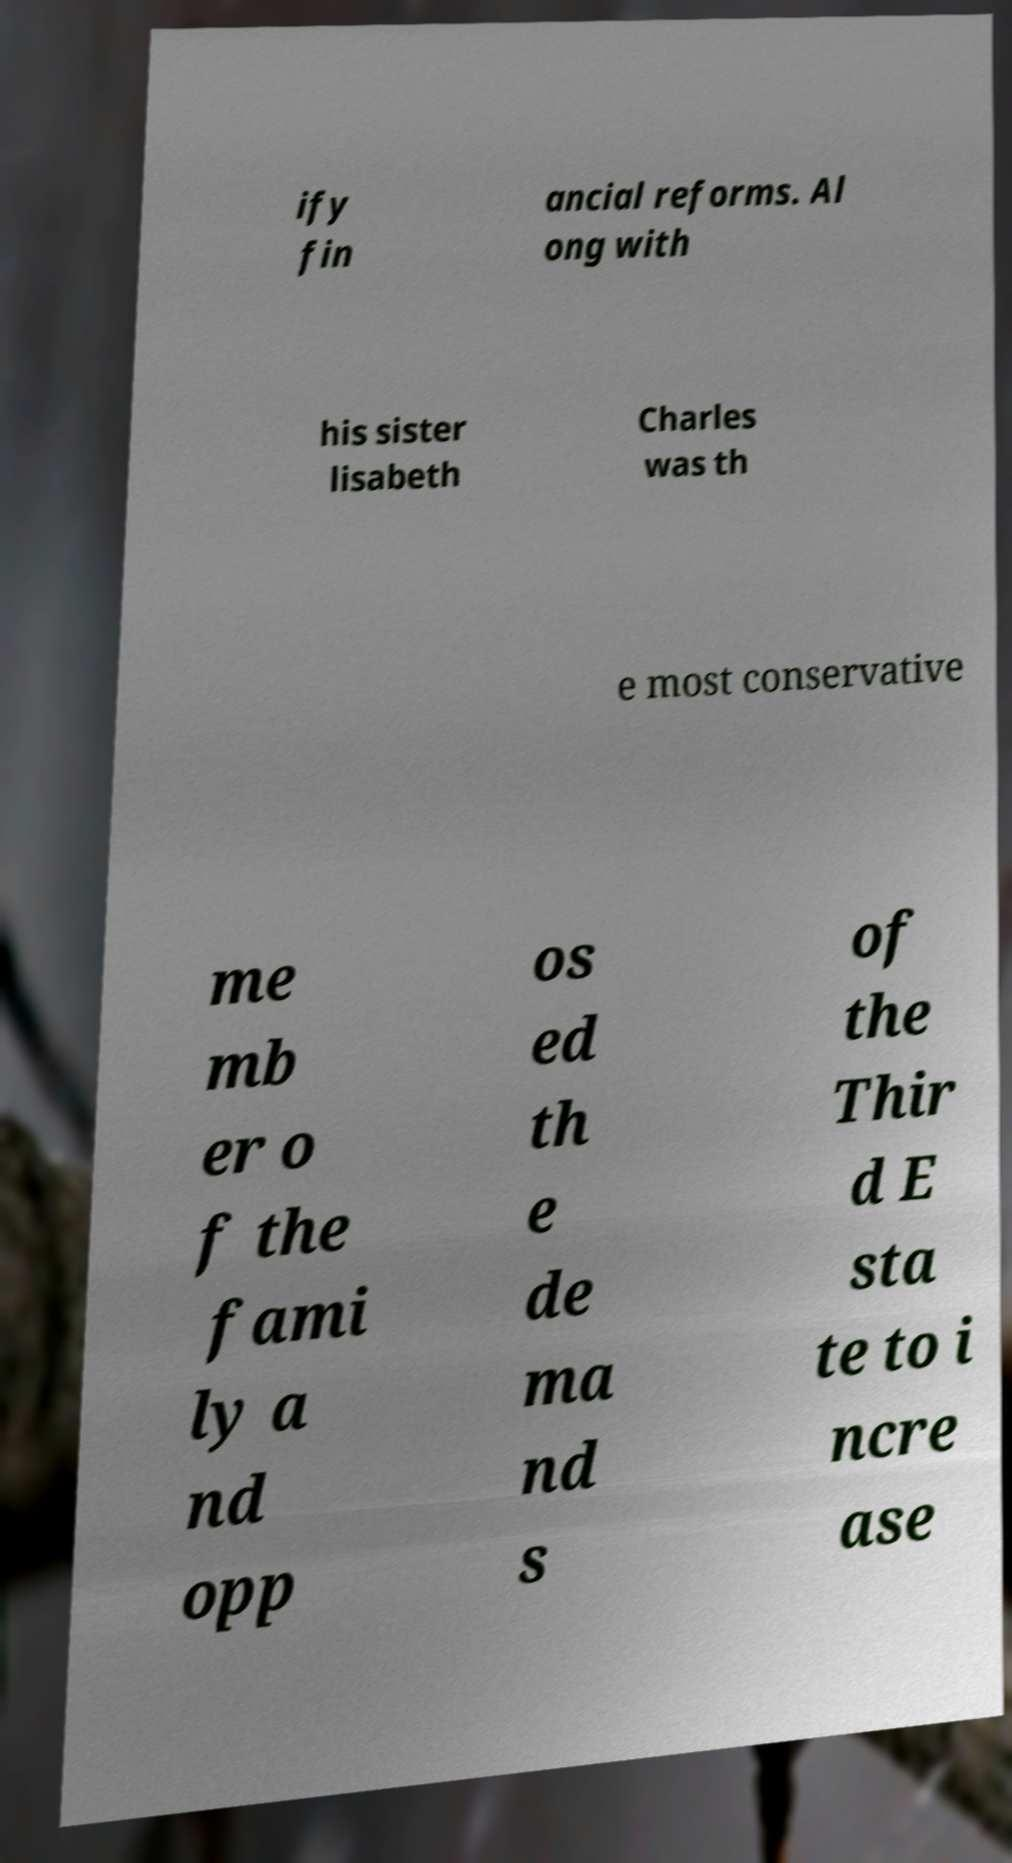I need the written content from this picture converted into text. Can you do that? ify fin ancial reforms. Al ong with his sister lisabeth Charles was th e most conservative me mb er o f the fami ly a nd opp os ed th e de ma nd s of the Thir d E sta te to i ncre ase 